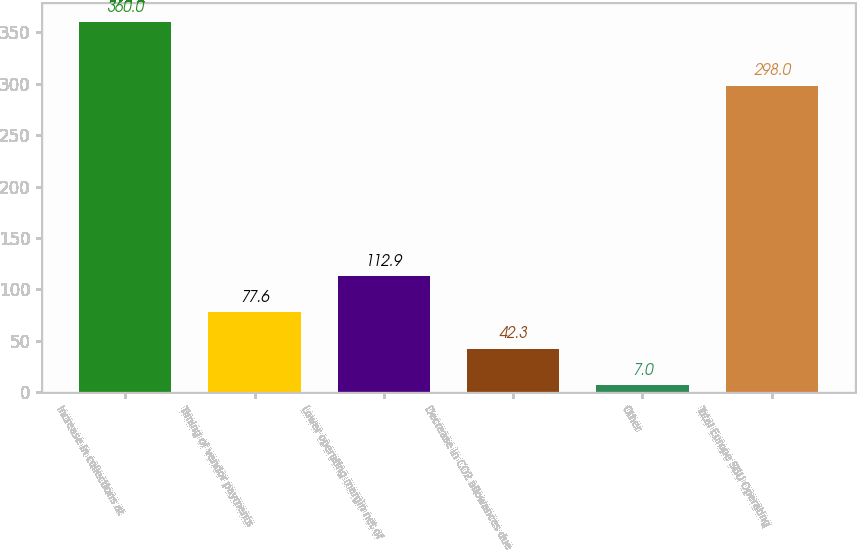Convert chart. <chart><loc_0><loc_0><loc_500><loc_500><bar_chart><fcel>Increase in collections at<fcel>Timing of vendor payments<fcel>Lower operating margin net of<fcel>Decrease in CO2 allowances due<fcel>Other<fcel>Total Europe SBU Operating<nl><fcel>360<fcel>77.6<fcel>112.9<fcel>42.3<fcel>7<fcel>298<nl></chart> 